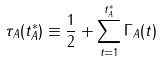Convert formula to latex. <formula><loc_0><loc_0><loc_500><loc_500>\tau _ { A } ( t _ { A } ^ { * } ) \equiv \frac { 1 } { 2 } + \sum _ { t = 1 } ^ { t _ { A } ^ { * } } \Gamma _ { A } ( t )</formula> 